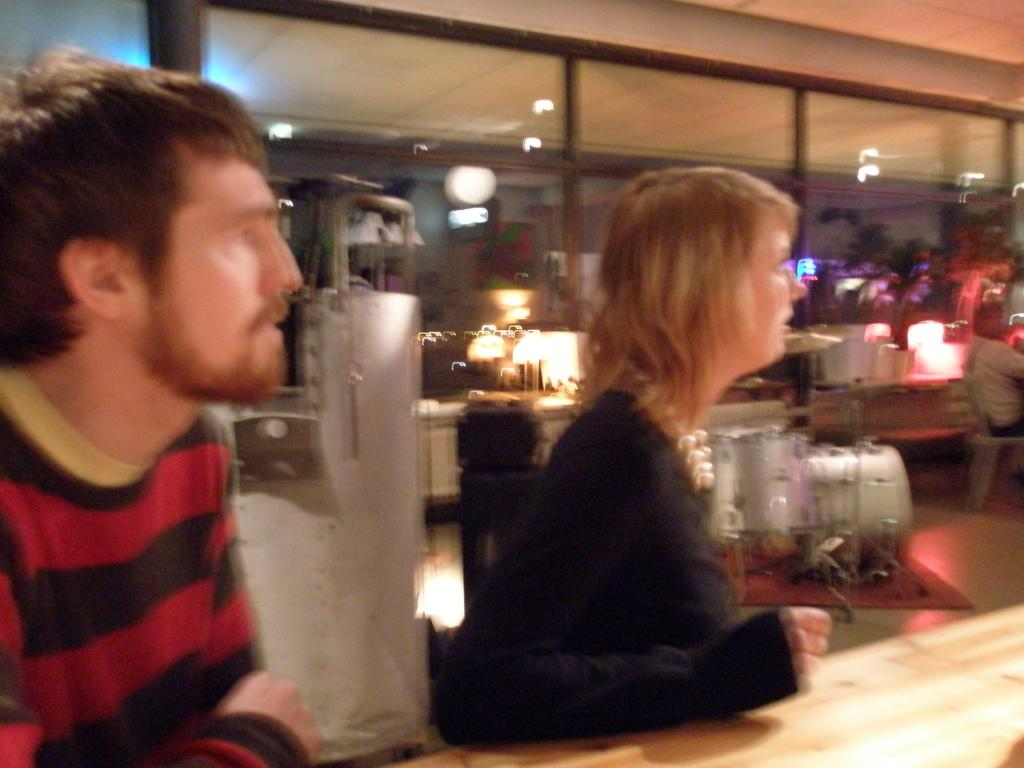How many people are present in the image? There are two people standing in the image. What is in front of the people? There is a table in front of the people. What can be seen through the windows in the image? The windows are visible in the image, but their contents cannot be determined due to the blurred background. Can you describe the background of the image? The background of the image is blurred. What type of coal is being burned by the people in the image? There is no coal or burning activity present in the image. How are the people pushing the table in the image? There is no indication that the people are pushing the table in the image; they are simply standing in front of it. 